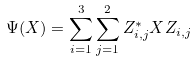Convert formula to latex. <formula><loc_0><loc_0><loc_500><loc_500>\Psi ( X ) = \sum _ { i = 1 } ^ { 3 } \sum _ { j = 1 } ^ { 2 } Z _ { i , j } ^ { * } X Z _ { i , j }</formula> 